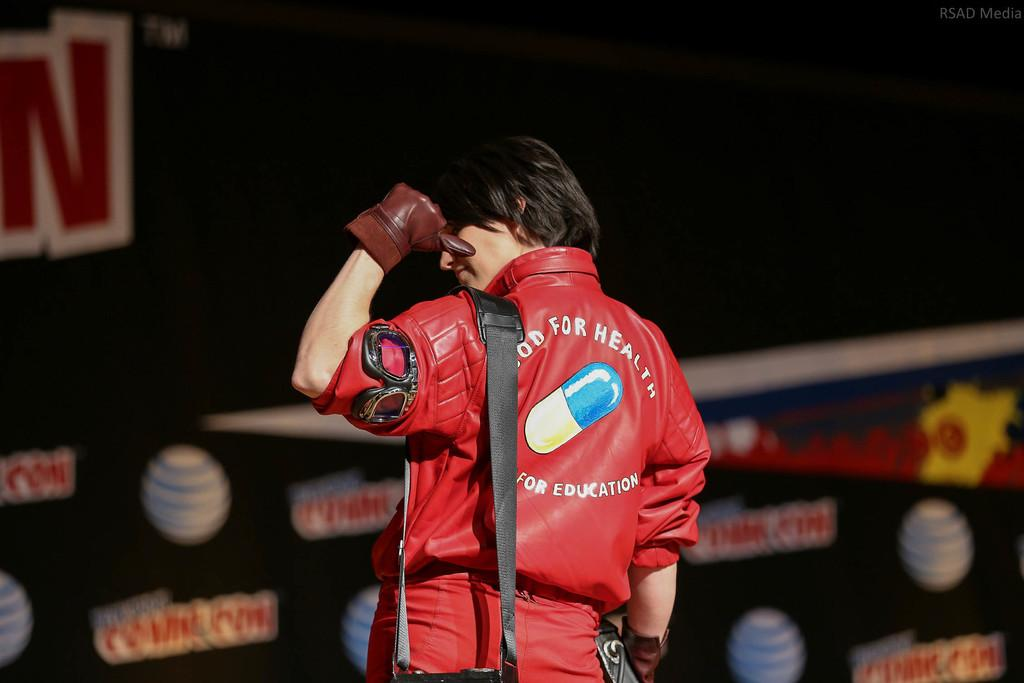Provide a one-sentence caption for the provided image. A person points to the picture of a pill on the back of their shirt with the words for education below it. 